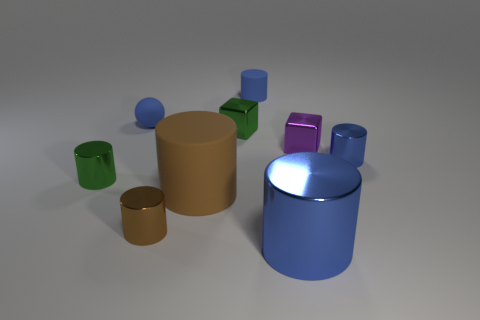What colors are the cylindrical objects in the image? The cylindrical objects in the image are green, purple, blue, and brown. 